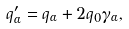<formula> <loc_0><loc_0><loc_500><loc_500>q _ { \alpha } ^ { \prime } = q _ { \alpha } + 2 q _ { 0 } \gamma _ { \alpha } ,</formula> 